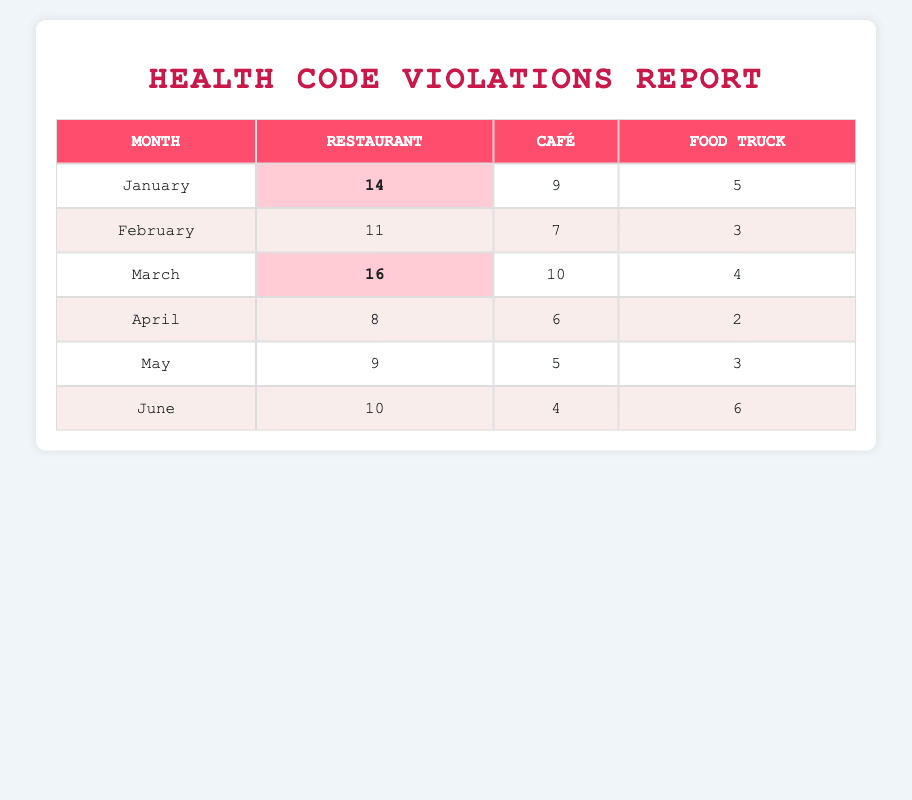What month had the highest number of health code violations in restaurants? By checking the values for the "Restaurant" column, January has 14 violations, February has 11, March has 16, April has 8, May has 9, and June has 10. March has the highest count at 16.
Answer: March How many total violations were recorded in Cafés for the first half of the year? To find the total violations in Cafés, we sum the violations from January (9), February (7), March (10), April (6), May (5), and June (4). The total is 9 + 7 + 10 + 6 + 5 + 4 = 41.
Answer: 41 Is the number of violations for Food Trucks consistent across the months? Looking at the Food Truck violations: January has 5, February has 3, March has 4, April has 2, May has 3, and June has 6. The numbers vary, indicating inconsistency.
Answer: No Which type of food establishment had the least violations in April? In April, the violation counts are: Restaurants (8), Cafés (6), and Food Trucks (2). The Food Truck had the least violations with 2.
Answer: Food Truck What is the average number of violations for Restaurants from January to June? We take the Restaurant violations for each month: January (14), February (11), March (16), April (8), May (9), June (10). The average is calculated by summing these values (14 + 11 + 16 + 8 + 9 + 10 = 68) and then dividing by 6 (68/6 = 11.33).
Answer: 11.33 Which month had the highest combined health code violations across all types of food establishments? We sum the violations for all establishment types per month: January (14 + 9 + 5 = 28), February (11 + 7 + 3 = 21), March (16 + 10 + 4 = 30), April (8 + 6 + 2 = 16), May (9 + 5 + 3 = 17), June (10 + 4 + 6 = 20). March has the highest at 30.
Answer: March Was there a month where Cafés had more violations than Restaurants? In each month, we compare the violations: January (Café 9, Restaurant 14), February (Café 7, Restaurant 11), March (Café 10, Restaurant 16), April (Café 6, Restaurant 8), May (Café 5, Restaurant 9), June (Café 4, Restaurant 10). In none of the months did Cafés exceed the Restaurant violations.
Answer: No What is the total number of health code violations recorded in June? For June, the recorded violations are: Restaurant (10), Café (4), and Food Truck (6). The total is 10 + 4 + 6 = 20.
Answer: 20 